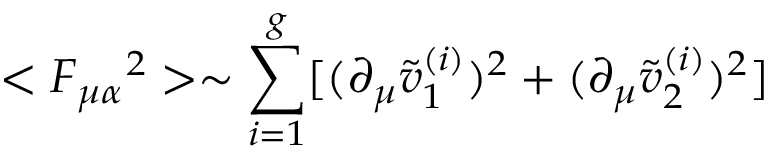<formula> <loc_0><loc_0><loc_500><loc_500>< F _ { \mu \alpha } ^ { \quad 2 } > \sim \sum _ { i = 1 } ^ { g } [ ( \partial _ { \mu } \tilde { v } _ { 1 } ^ { ( i ) } ) ^ { 2 } + ( \partial _ { \mu } \tilde { v } _ { 2 } ^ { ( i ) } ) ^ { 2 } ]</formula> 